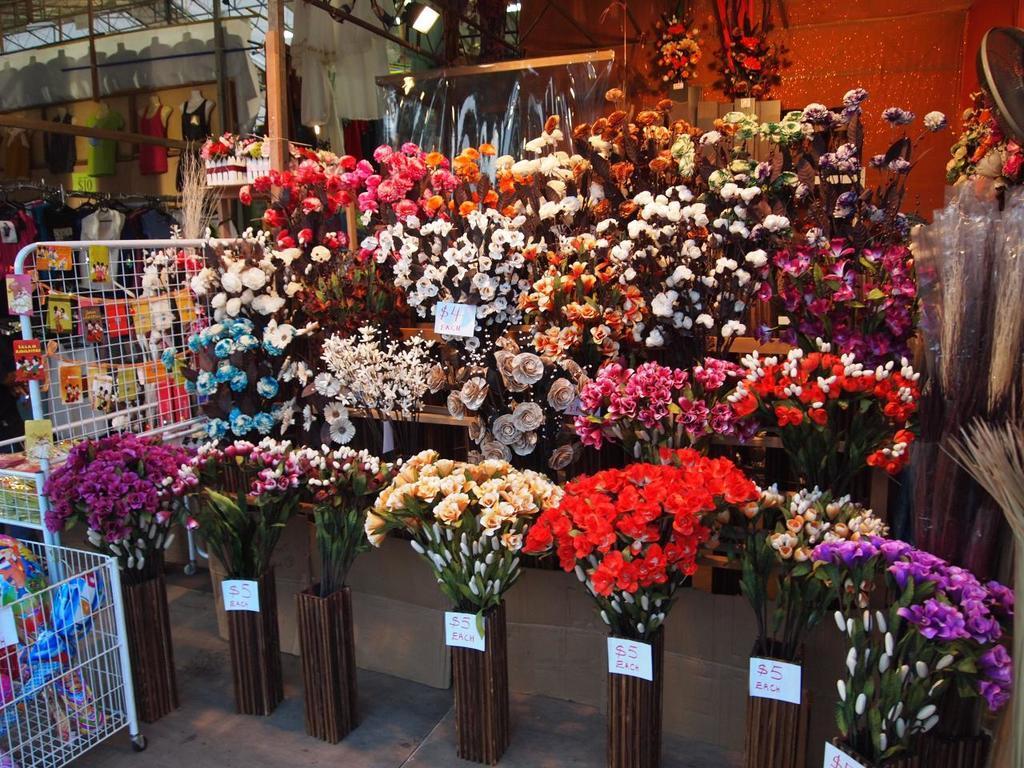How would you summarize this image in a sentence or two? In the image we can see there are many flower bookies and there are many different colors of flowers. This is a floor, stairs, fence, pole, price tag, wall, body mannequin and a roof. 